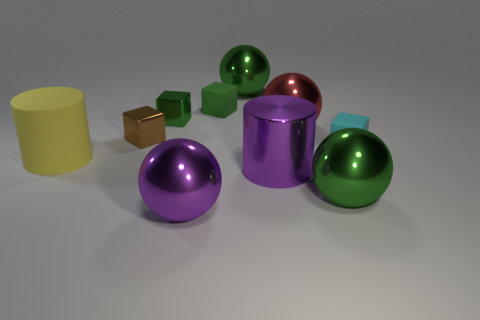What is the texture of the objects present in the image? The objects in the image appear to have varied textures. The spheres and the cylinder show reflective surfaces, hinting at a smooth and potentially metal-like texture. In contrast, the solid-colored blocks seem to have a flatter, more matte finish, suggesting a possible plastic or wooden texture. Do the colors of the objects seem realistic? The colors of the objects are vivid and varied, ranging from metallic shades to bright solid hues. While the colors could exist in reality, particularly for manufactured items, their perfectly clean and uniform appearance gives them a slightly artificial, computer-generated quality. 